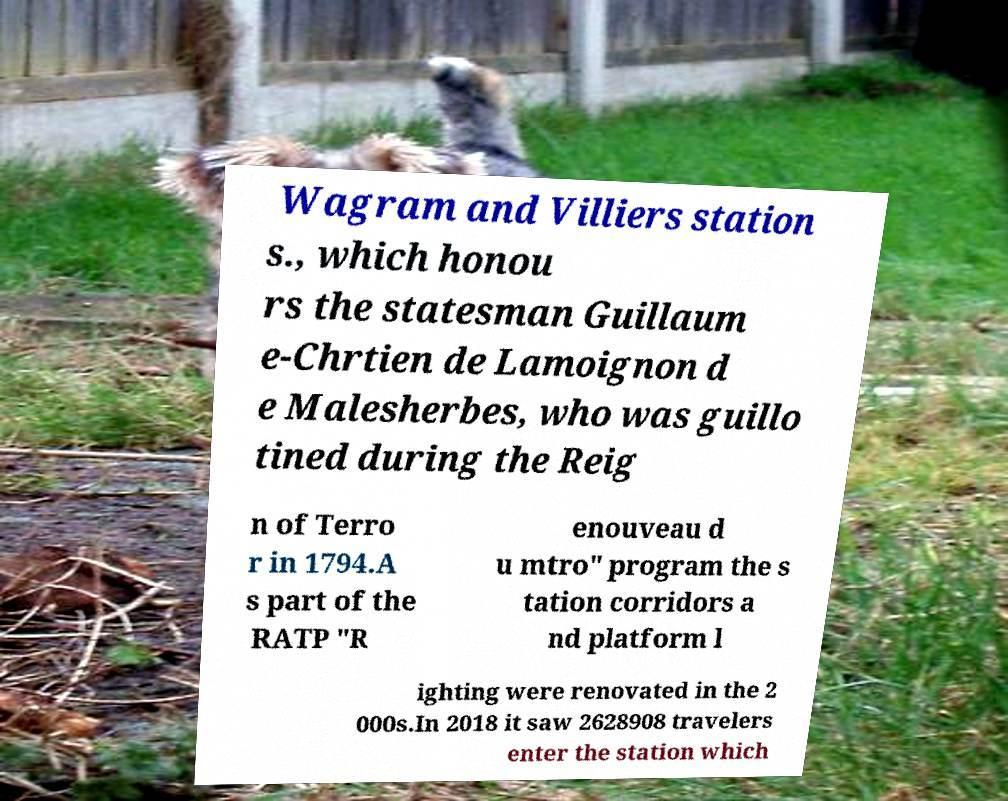Please read and relay the text visible in this image. What does it say? Wagram and Villiers station s., which honou rs the statesman Guillaum e-Chrtien de Lamoignon d e Malesherbes, who was guillo tined during the Reig n of Terro r in 1794.A s part of the RATP "R enouveau d u mtro" program the s tation corridors a nd platform l ighting were renovated in the 2 000s.In 2018 it saw 2628908 travelers enter the station which 